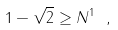Convert formula to latex. <formula><loc_0><loc_0><loc_500><loc_500>1 - \sqrt { 2 } \geq N ^ { 1 } \ ,</formula> 